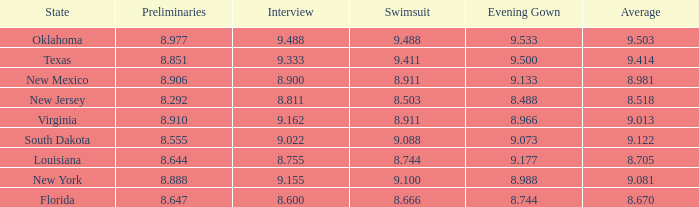 what's the evening gown where preliminaries is 8.977 9.533. 